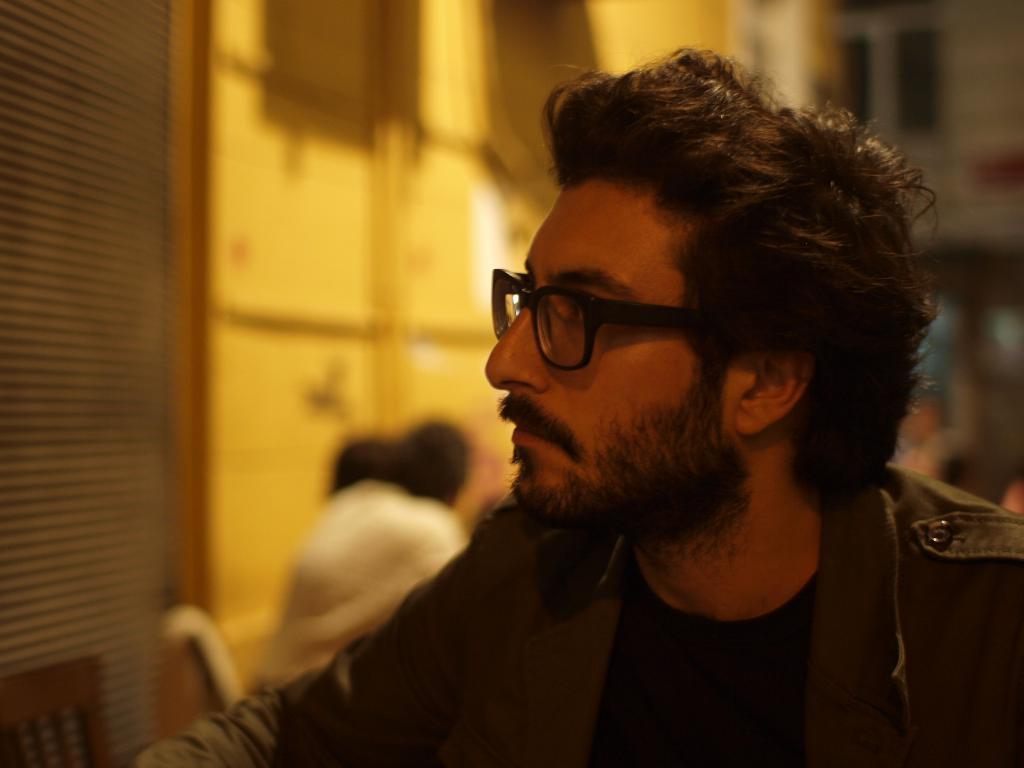Please provide a concise description of this image. In this image I can see a man is wearing a jacket and spectacles. The background of the image is blurred. 